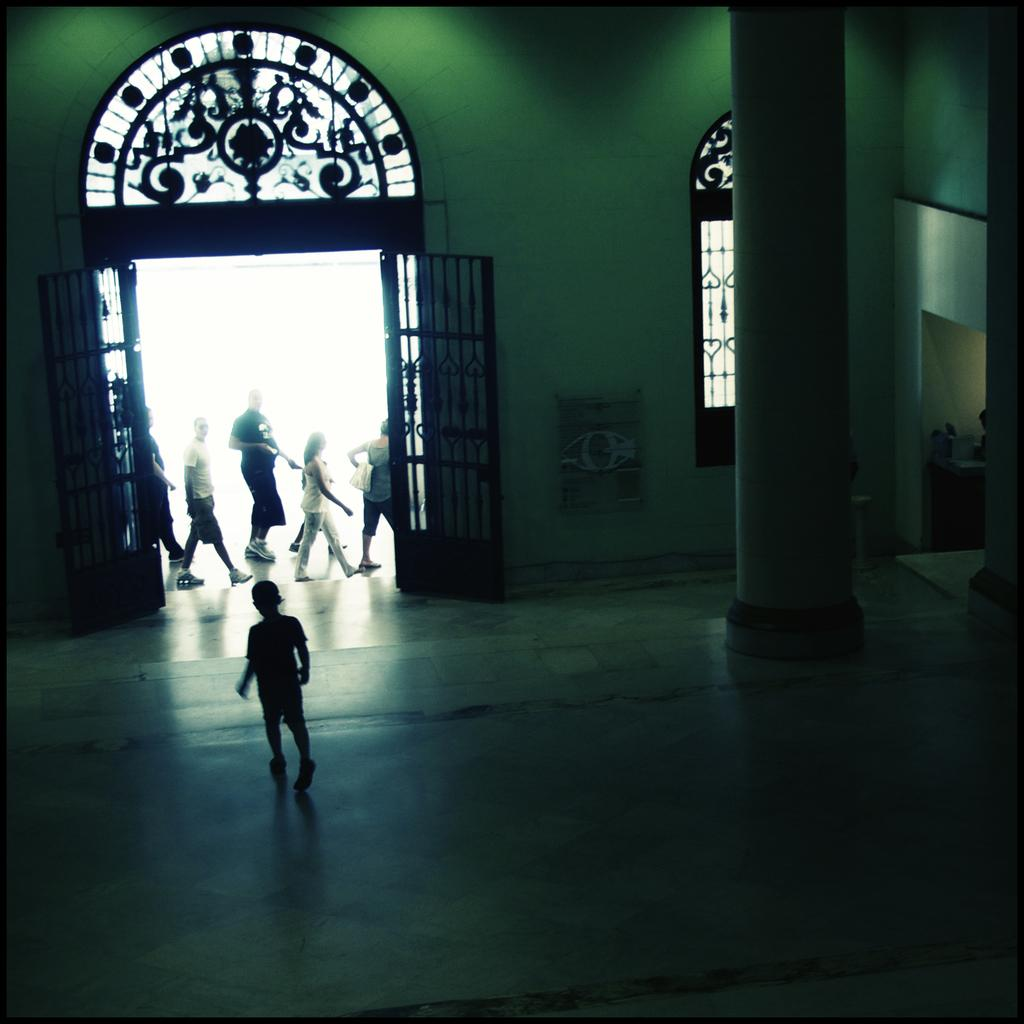What is the boy doing at the bottom of the image? The boy is walking at the bottom of the image. What can be seen on the right side of the image? There is a pillar on the right side of the image. What is visible in the background of the image? There is a wall, a door, people walking, and a window in the background of the image. How many dogs are blowing bubbles in the image? There are no dogs or bubbles present in the image. 